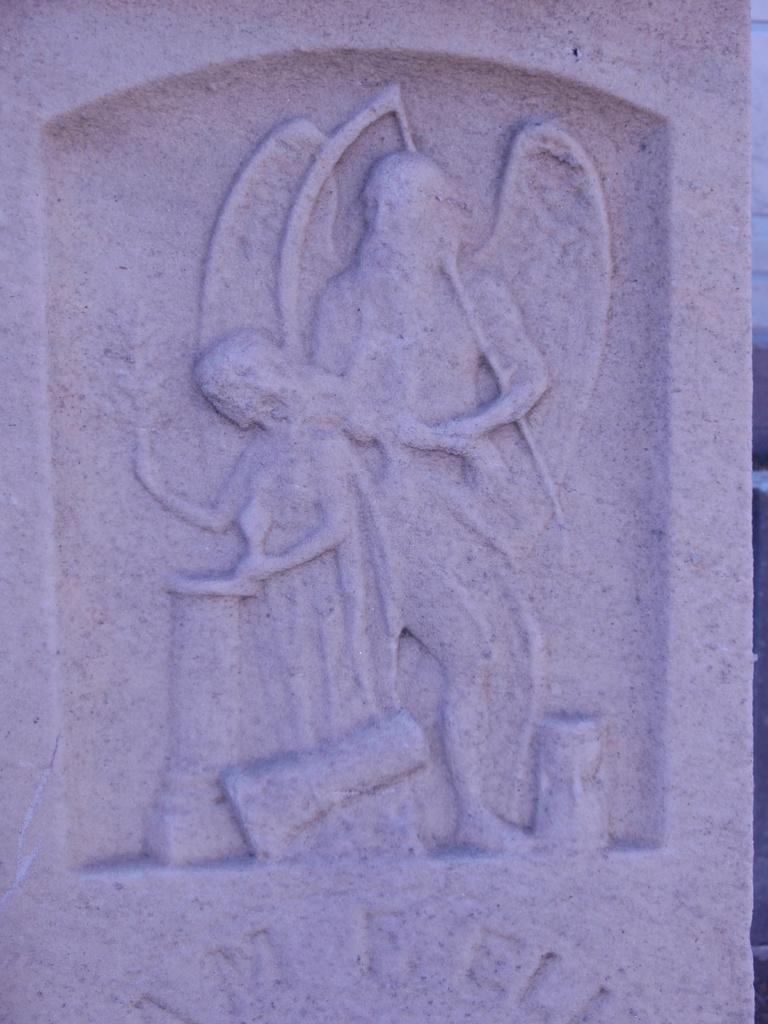What is the main subject of the image? The main subject of the image is a sculpture. What material is the sculpture made of? The sculpture is engraved on a stone. Can you see a kitten sitting comfortably on the coach in the image? There is no kitten or coach present in the image; it features a sculpture engraved on a stone. 